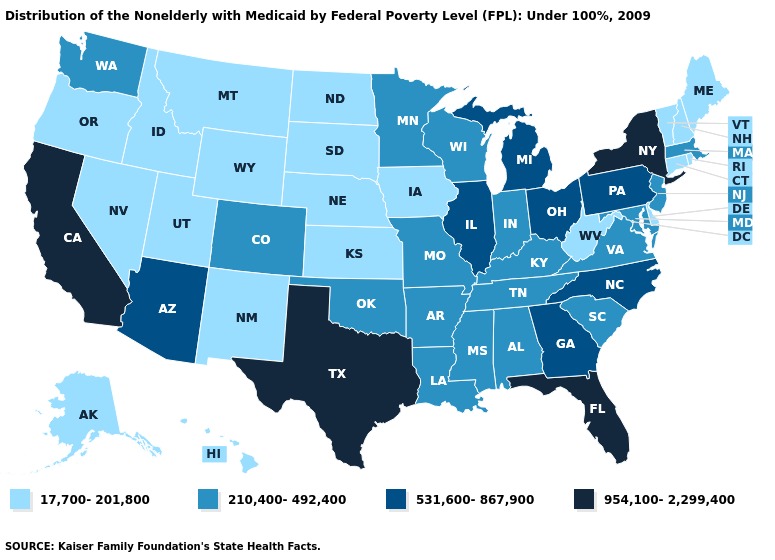What is the highest value in states that border Maryland?
Quick response, please. 531,600-867,900. What is the lowest value in states that border Oklahoma?
Be succinct. 17,700-201,800. What is the value of Michigan?
Write a very short answer. 531,600-867,900. What is the value of Minnesota?
Concise answer only. 210,400-492,400. Which states have the lowest value in the USA?
Short answer required. Alaska, Connecticut, Delaware, Hawaii, Idaho, Iowa, Kansas, Maine, Montana, Nebraska, Nevada, New Hampshire, New Mexico, North Dakota, Oregon, Rhode Island, South Dakota, Utah, Vermont, West Virginia, Wyoming. What is the lowest value in the Northeast?
Write a very short answer. 17,700-201,800. What is the lowest value in states that border Massachusetts?
Short answer required. 17,700-201,800. Which states have the lowest value in the USA?
Keep it brief. Alaska, Connecticut, Delaware, Hawaii, Idaho, Iowa, Kansas, Maine, Montana, Nebraska, Nevada, New Hampshire, New Mexico, North Dakota, Oregon, Rhode Island, South Dakota, Utah, Vermont, West Virginia, Wyoming. Name the states that have a value in the range 17,700-201,800?
Write a very short answer. Alaska, Connecticut, Delaware, Hawaii, Idaho, Iowa, Kansas, Maine, Montana, Nebraska, Nevada, New Hampshire, New Mexico, North Dakota, Oregon, Rhode Island, South Dakota, Utah, Vermont, West Virginia, Wyoming. Which states have the lowest value in the West?
Write a very short answer. Alaska, Hawaii, Idaho, Montana, Nevada, New Mexico, Oregon, Utah, Wyoming. Which states have the lowest value in the West?
Concise answer only. Alaska, Hawaii, Idaho, Montana, Nevada, New Mexico, Oregon, Utah, Wyoming. Does Indiana have the lowest value in the USA?
Quick response, please. No. What is the value of Nebraska?
Give a very brief answer. 17,700-201,800. Does the map have missing data?
Short answer required. No. 